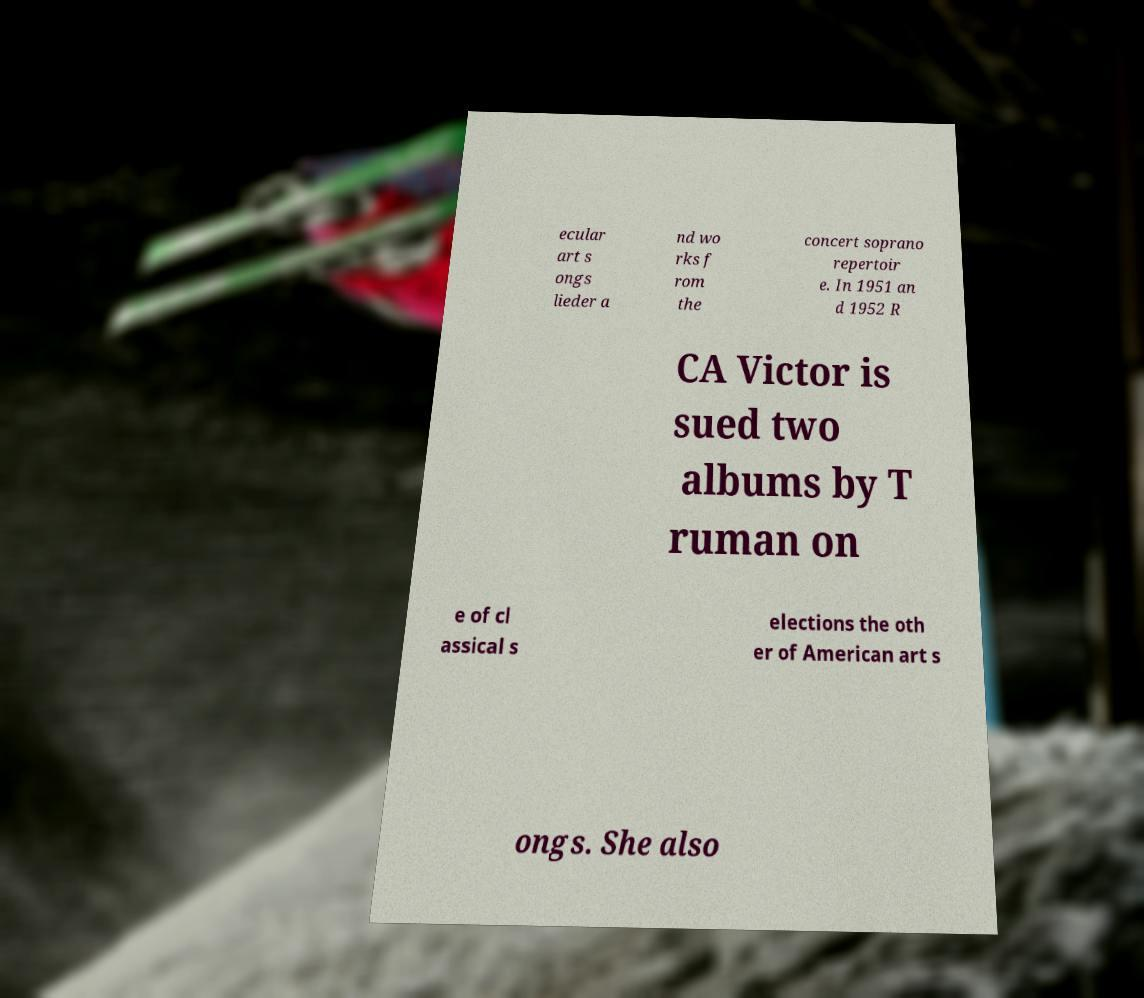What messages or text are displayed in this image? I need them in a readable, typed format. ecular art s ongs lieder a nd wo rks f rom the concert soprano repertoir e. In 1951 an d 1952 R CA Victor is sued two albums by T ruman on e of cl assical s elections the oth er of American art s ongs. She also 